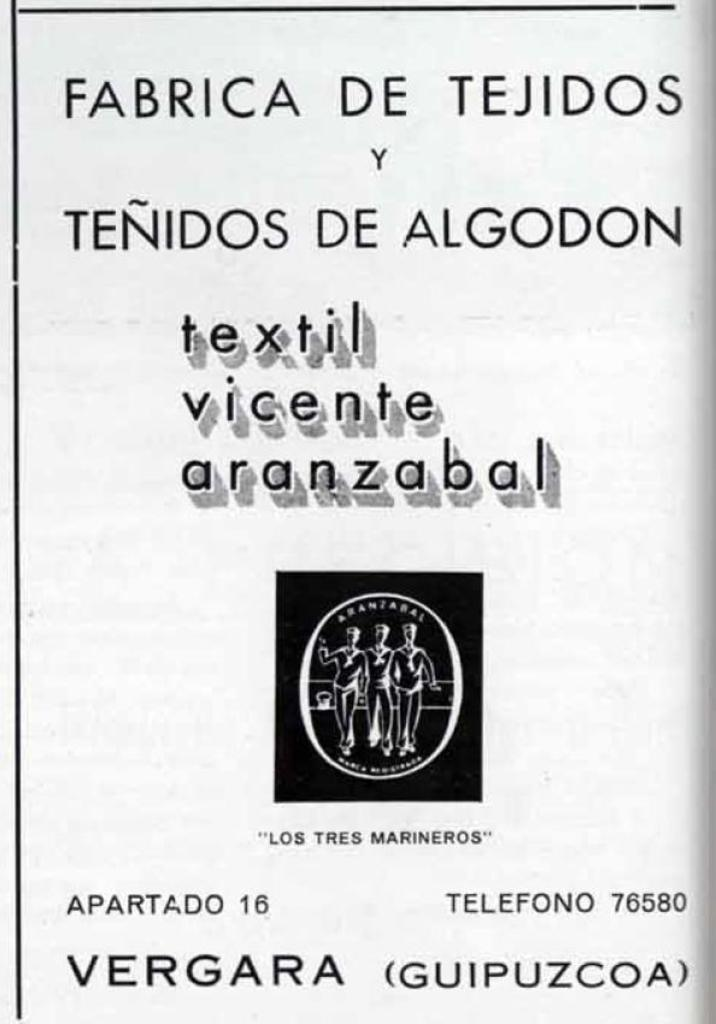What can be found on the poster in the image? There is text, numbers, images of people, and other things on the poster. Can you describe the images of people on the poster? The images of people on the poster depict various individuals. What type of information is conveyed by the numbers on the poster? The numbers on the poster provide specific details or data related to the content of the poster. Can you see a donkey walking down the street in the image? No, there is no donkey or street present in the image; it features a poster with text, numbers, images of people, and other things. 